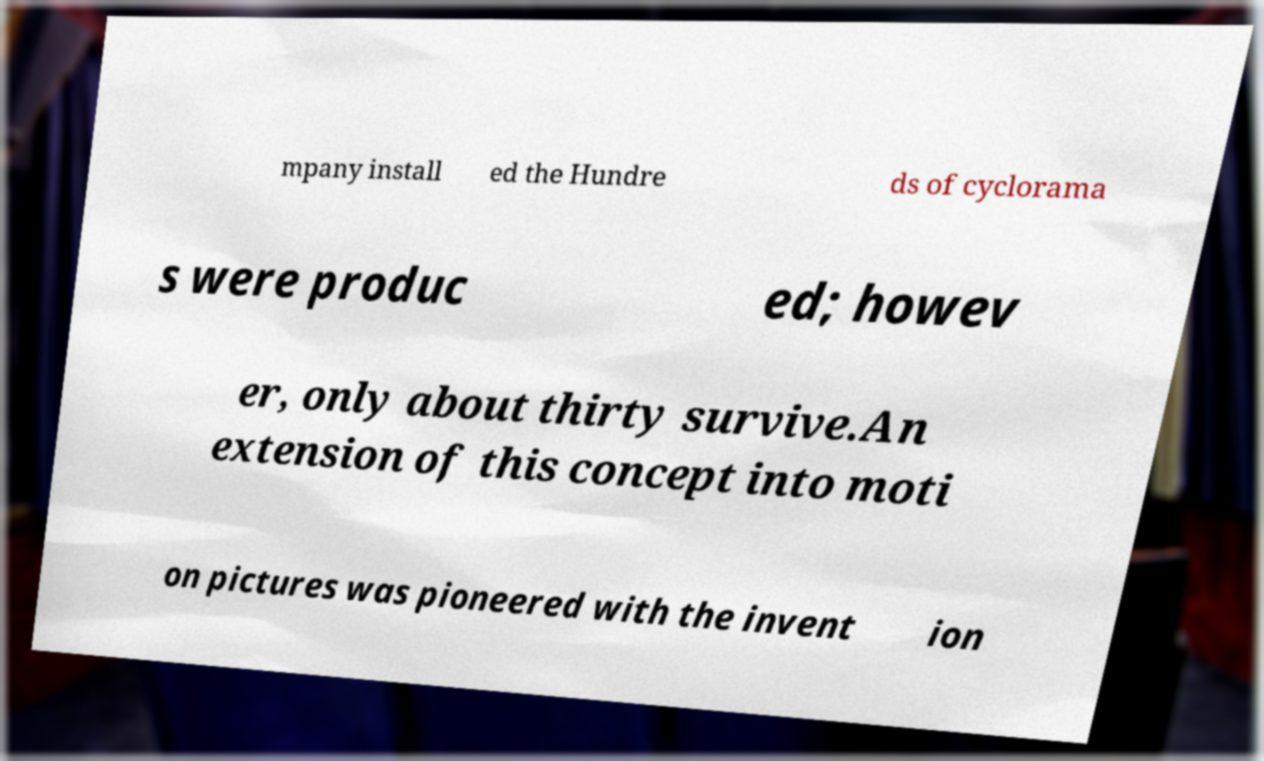I need the written content from this picture converted into text. Can you do that? mpany install ed the Hundre ds of cyclorama s were produc ed; howev er, only about thirty survive.An extension of this concept into moti on pictures was pioneered with the invent ion 